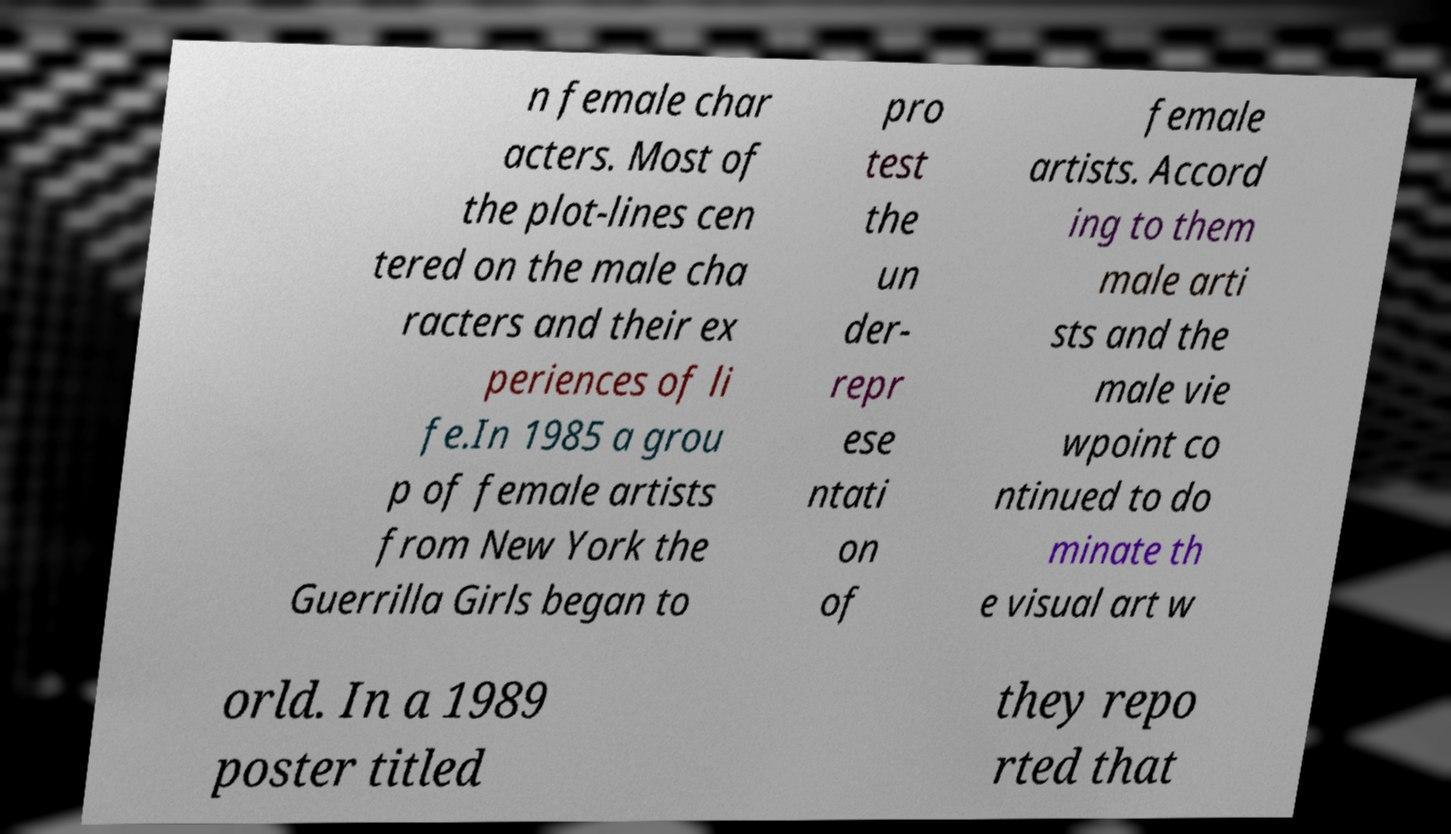What messages or text are displayed in this image? I need them in a readable, typed format. n female char acters. Most of the plot-lines cen tered on the male cha racters and their ex periences of li fe.In 1985 a grou p of female artists from New York the Guerrilla Girls began to pro test the un der- repr ese ntati on of female artists. Accord ing to them male arti sts and the male vie wpoint co ntinued to do minate th e visual art w orld. In a 1989 poster titled they repo rted that 